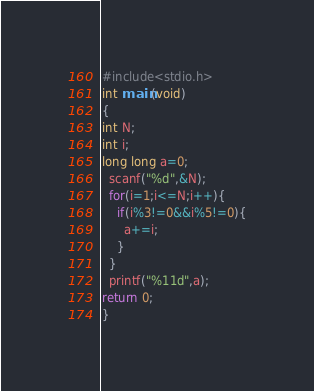Convert code to text. <code><loc_0><loc_0><loc_500><loc_500><_C_>#include<stdio.h>
int main(void)
{
int N;
int i;
long long a=0;
  scanf("%d",&N); 
  for(i=1;i<=N;i++){
	if(i%3!=0&&i%5!=0){
	  a+=i;
	}  
  }	
  printf("%11d",a);
return 0;	
}
</code> 